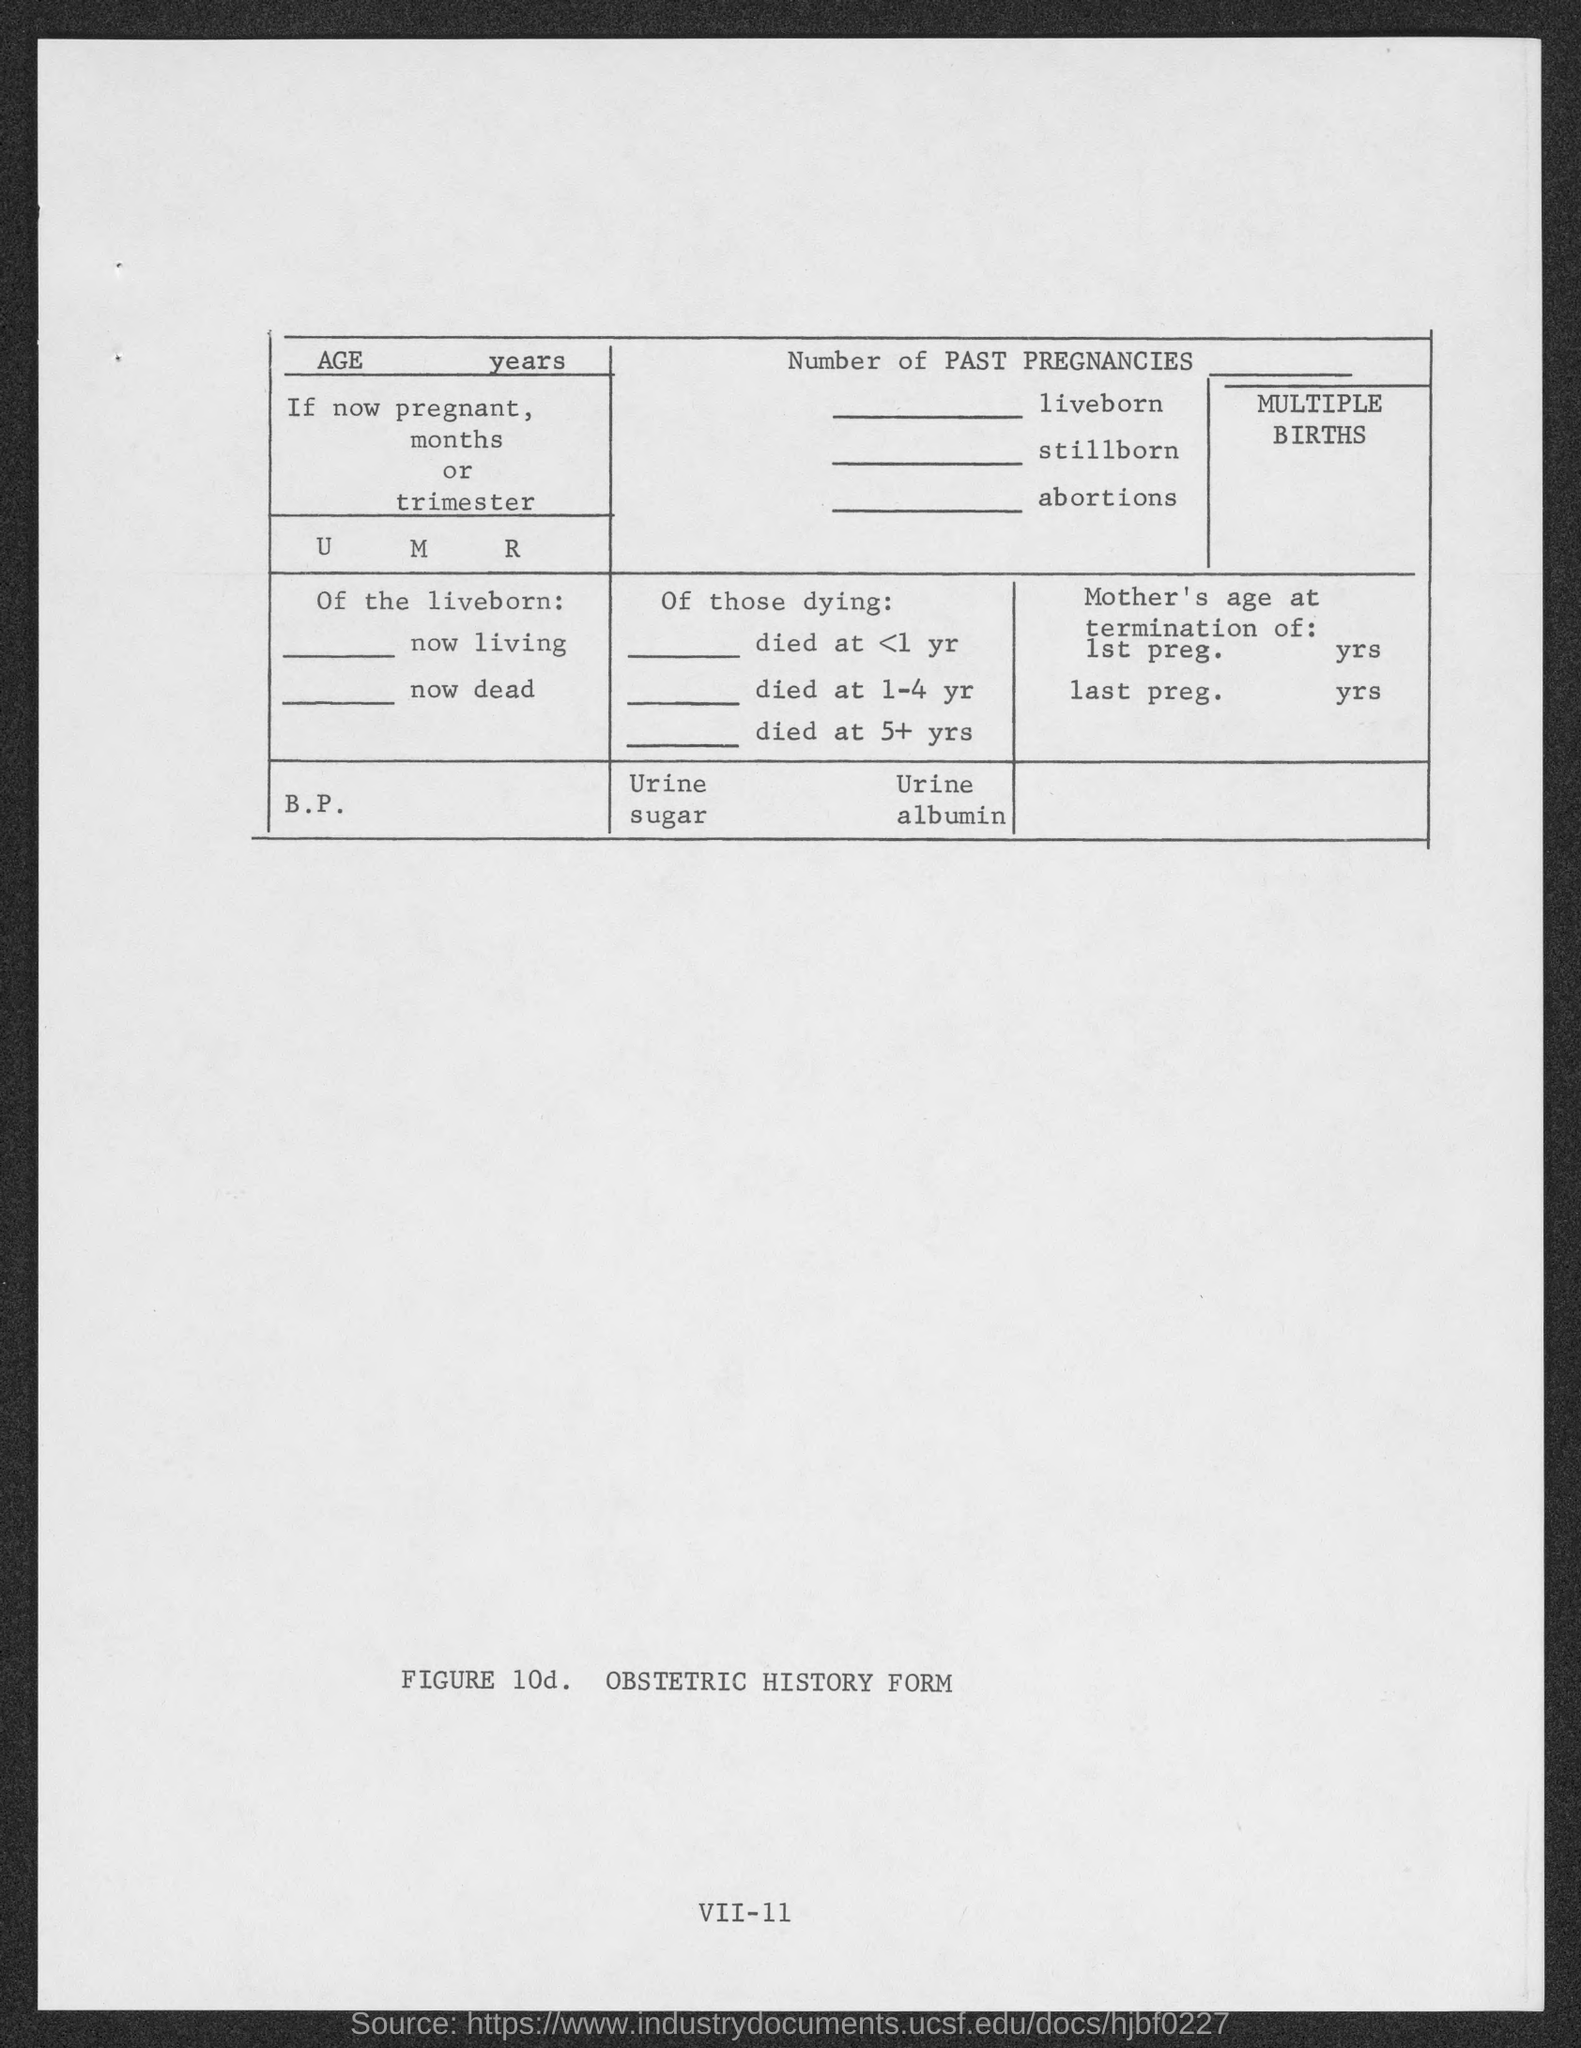What is the name of the form?
Offer a terse response. Obstetric history form. 